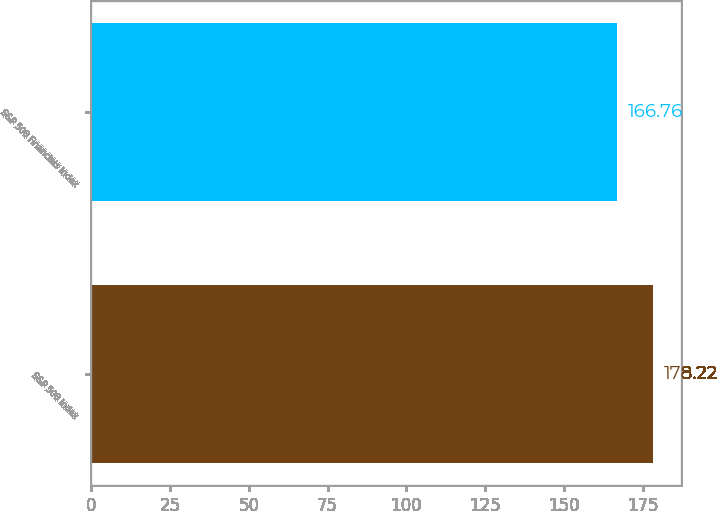<chart> <loc_0><loc_0><loc_500><loc_500><bar_chart><fcel>S&P 500 Index<fcel>S&P 500 Financials Index<nl><fcel>178.22<fcel>166.76<nl></chart> 